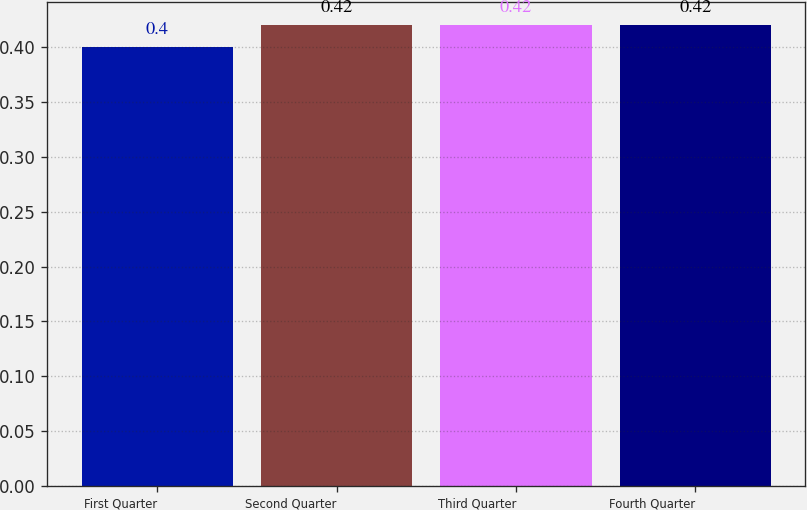Convert chart to OTSL. <chart><loc_0><loc_0><loc_500><loc_500><bar_chart><fcel>First Quarter<fcel>Second Quarter<fcel>Third Quarter<fcel>Fourth Quarter<nl><fcel>0.4<fcel>0.42<fcel>0.42<fcel>0.42<nl></chart> 